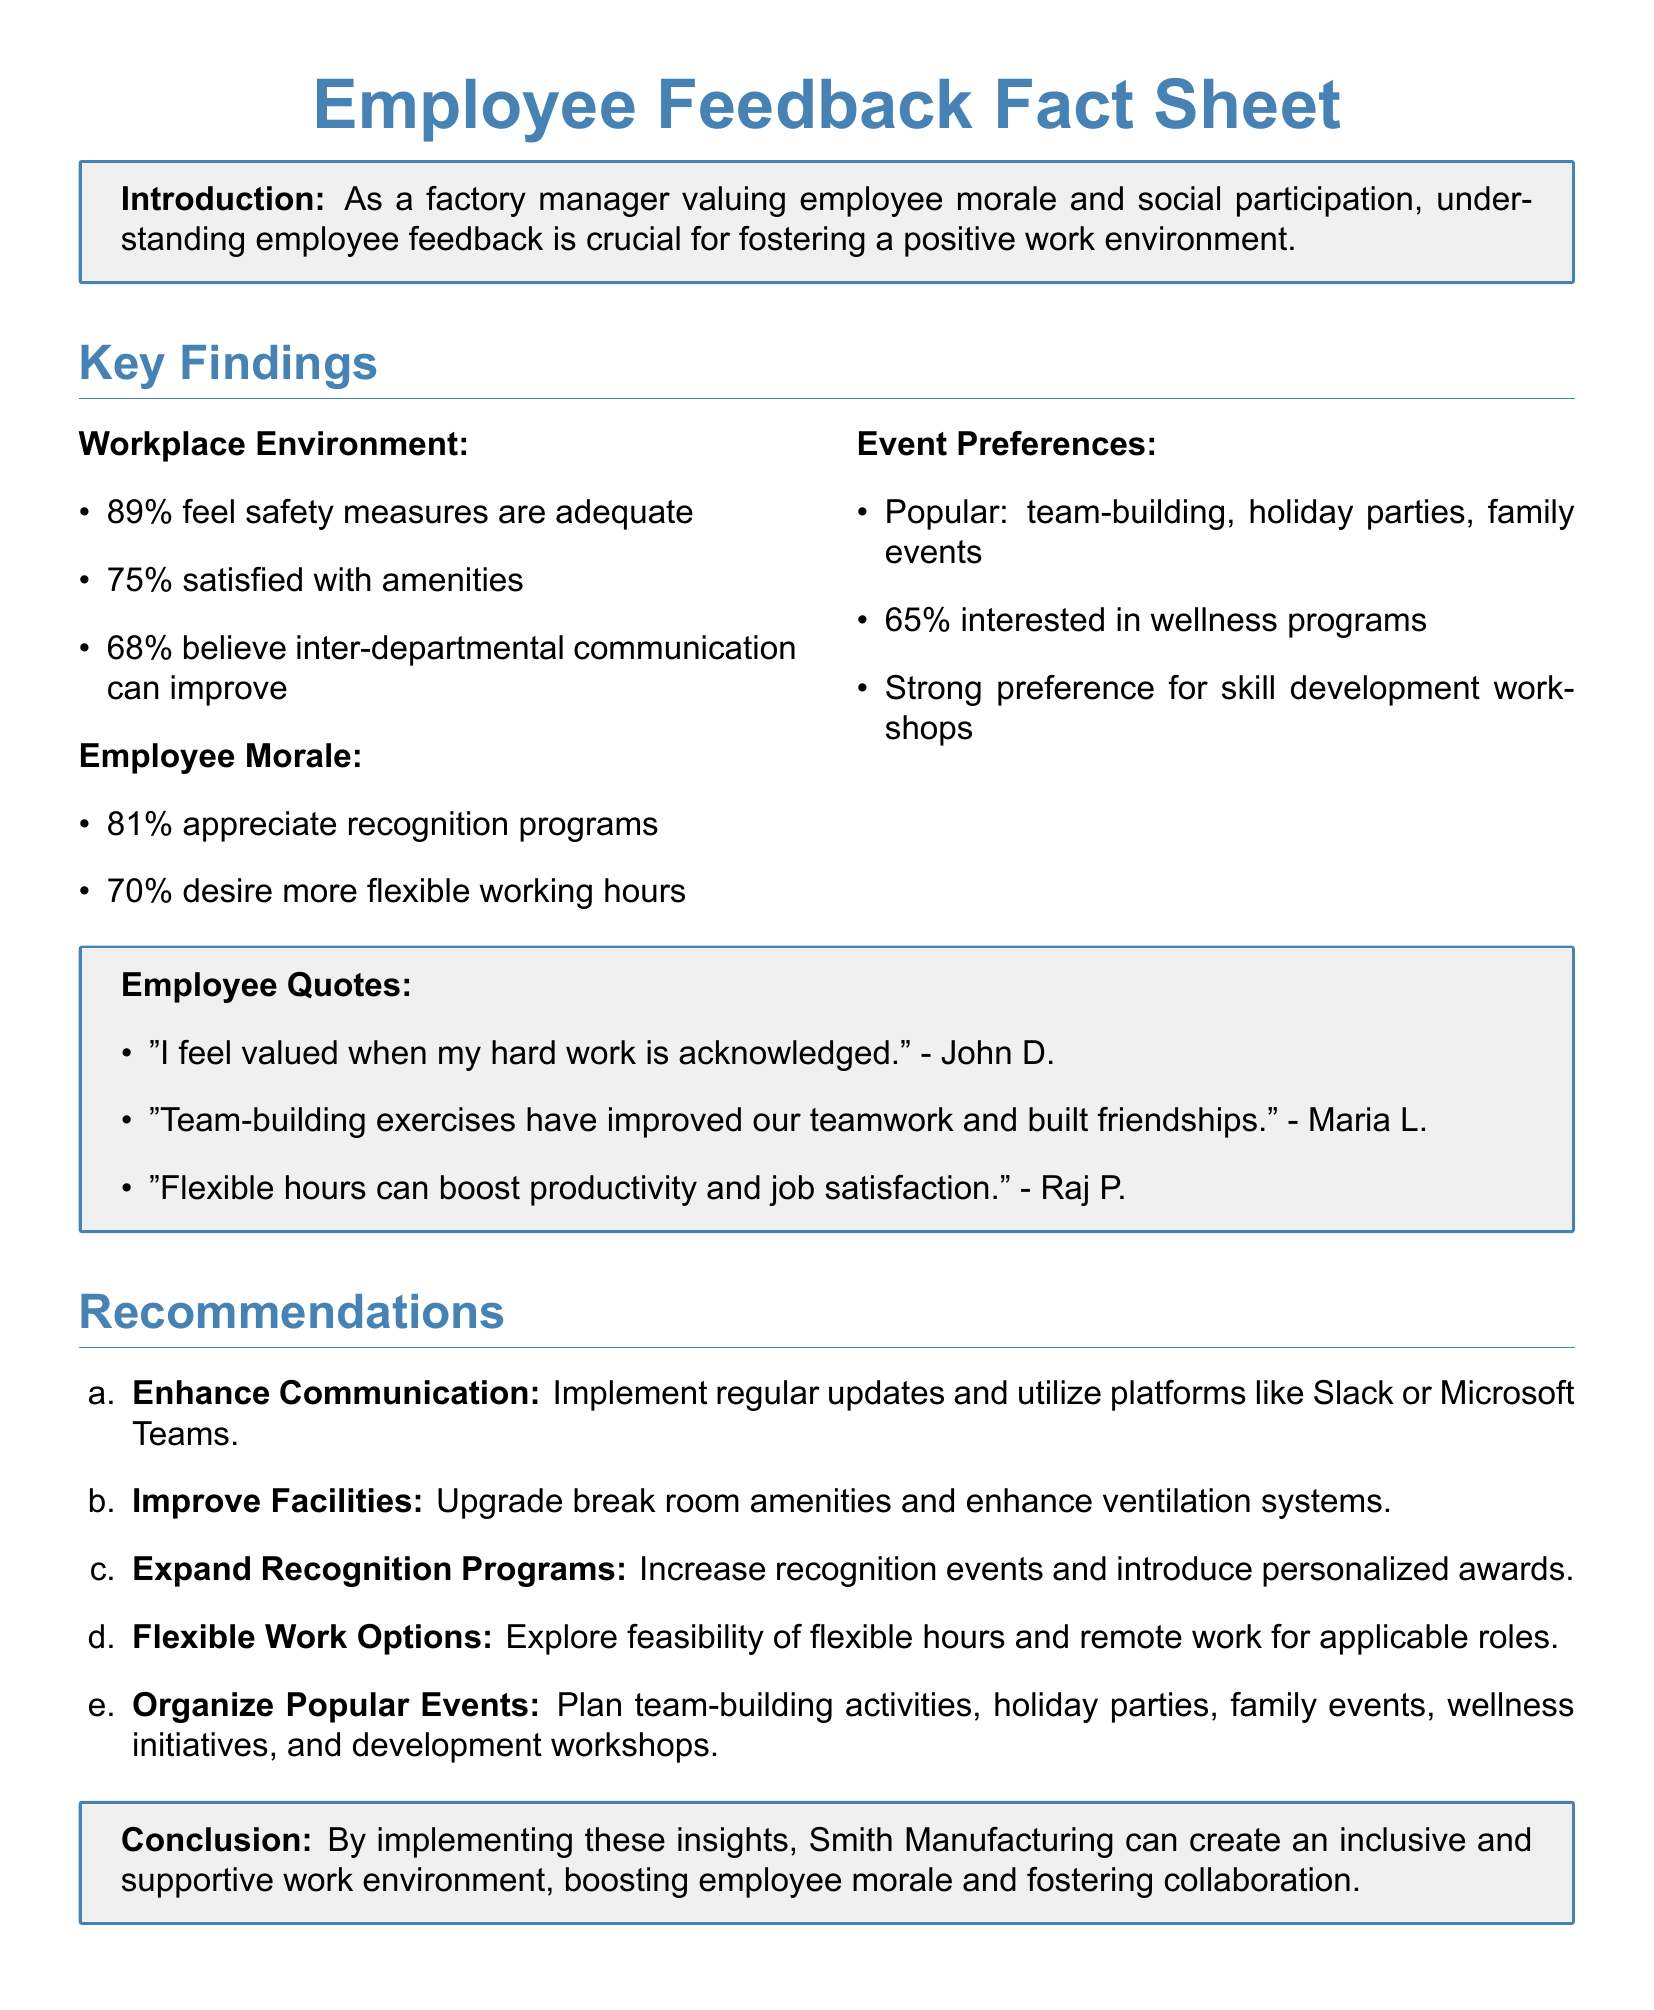What percentage of employees feel safety measures are adequate? The document states that 89% of employees feel safety measures are adequate.
Answer: 89% What is the primary reason employees appreciate recognition programs? According to employee quotes, they feel valued when their hard work is acknowledged.
Answer: Valued What percentage of employees desire more flexible working hours? The fact sheet indicates that 70% of employees desire more flexible working hours.
Answer: 70% Which types of events are most popular among employees? The document lists team-building, holiday parties, and family events as the most popular.
Answer: Team-building, holiday parties, family events What recommendation addresses inter-departmental communication improvement? The recommendation to enhance communication suggests implementing regular updates and utilizing platforms like Slack or Microsoft Teams.
Answer: Enhance Communication What is the major preference indicated for development? The employees have a strong preference for skill development workshops.
Answer: Skill development workshops Who is quoted saying that flexible hours can boost productivity? The quote comes from Raj P., who mentioned that flexible hours can boost productivity and job satisfaction.
Answer: Raj P What type of work options does the recommendation suggest to explore? The recommendation suggests exploring the feasibility of flexible hours and remote work for applicable roles.
Answer: Flexible work options 